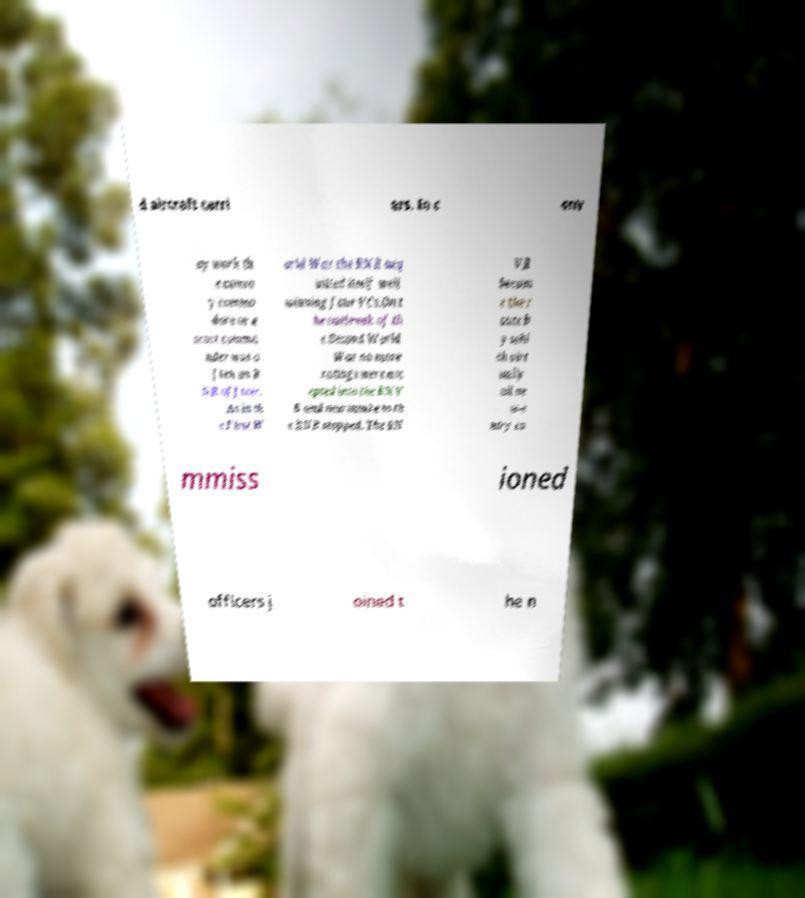Please identify and transcribe the text found in this image. d aircraft carri ers. In c onv oy work th e convo y commo dore or e scort comma nder was o ften an R NR officer. As in th e First W orld War the RNR acq uitted itself well winning four VCs.On t he outbreak of th e Second World War no more ratings were acc epted into the RNV R and new intake to th e RNR stopped. The RN VR becam e the r oute b y whi ch virt ually all ne w-e ntry co mmiss ioned officers j oined t he n 